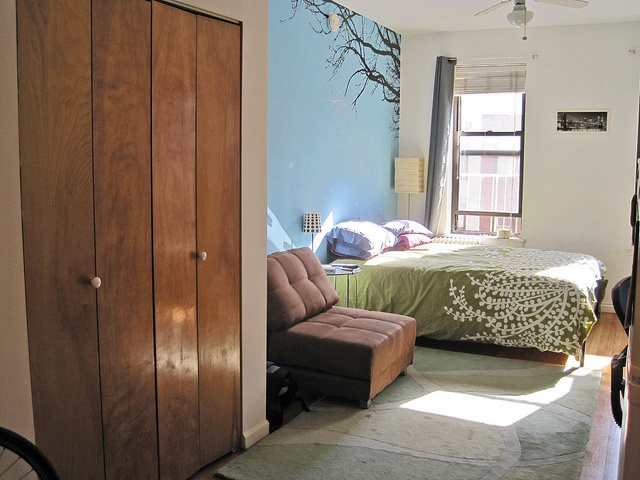Describe the objects in this image and their specific colors. I can see bed in gray, darkgray, darkgreen, and white tones, couch in gray, black, brown, and darkgray tones, and chair in gray, black, darkgray, and brown tones in this image. 